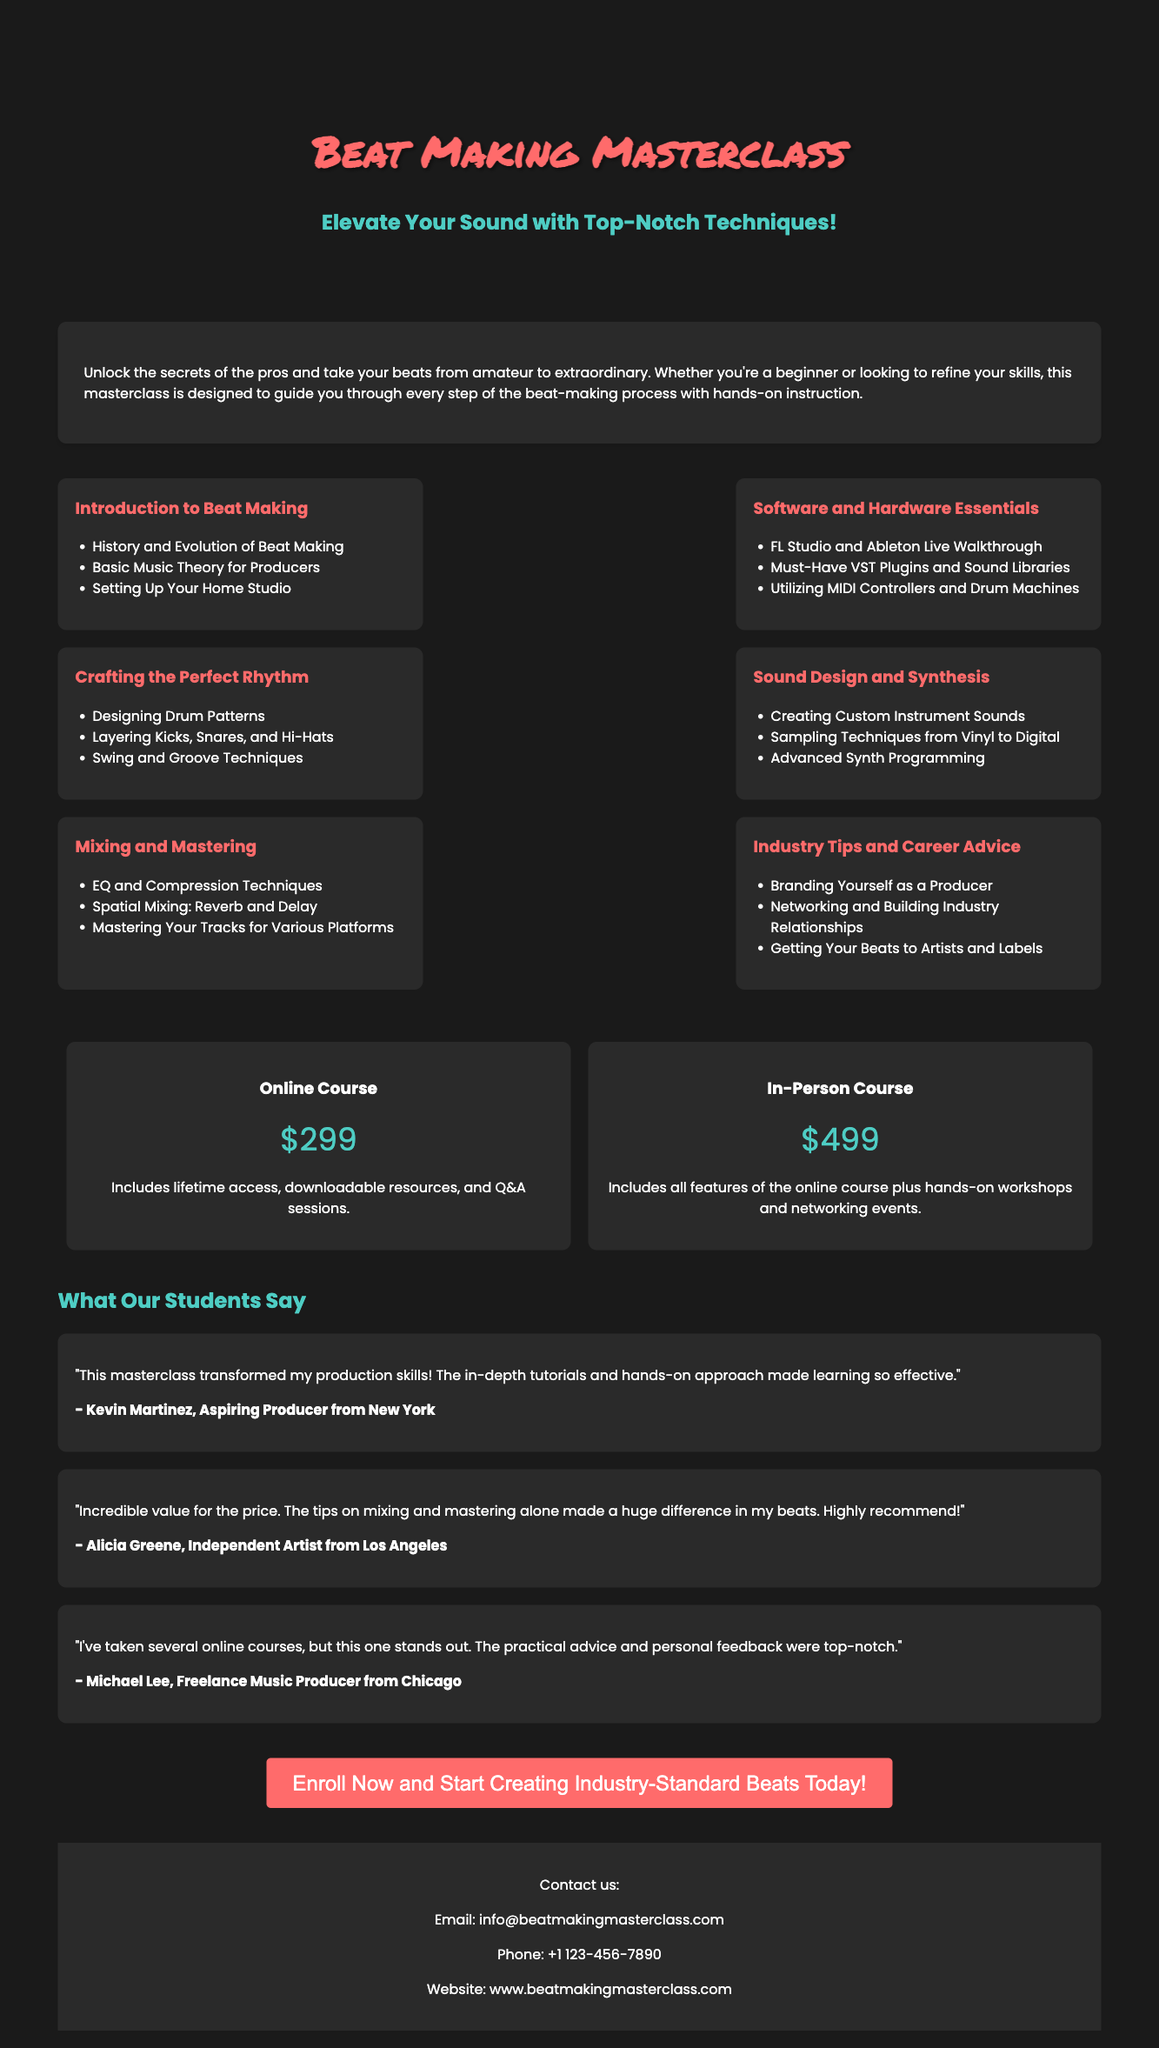What is the title of the masterclass? The title is prominently displayed in the header section of the advertisement.
Answer: Beat Making Masterclass What is the price of the online course? The pricing section clearly lists the cost for each course option.
Answer: $299 What is one benefit of enrolling in the in-person course? The details for the in-person course mention unique features that enhance the learning experience.
Answer: Hands-on workshops Which software is discussed in the curriculum? The curriculum outlines specific software that will be covered in the course modules.
Answer: FL Studio and Ableton Live Who is a past participant that gave a testimonial? The testimonials section provides names of past participants that highlight their experiences.
Answer: Kevin Martinez What is the contact email for the masterclass? Contact information is included in the footer of the document.
Answer: info@beatmakingmasterclass.com How many modules are listed in the curriculum? By counting the listed curriculum modules, the total number can be identified.
Answer: Six What is a key topic in the "Industry Tips and Career Advice" module? This module includes specific topics that provide practical insights for producers.
Answer: Branding Yourself as a Producer 